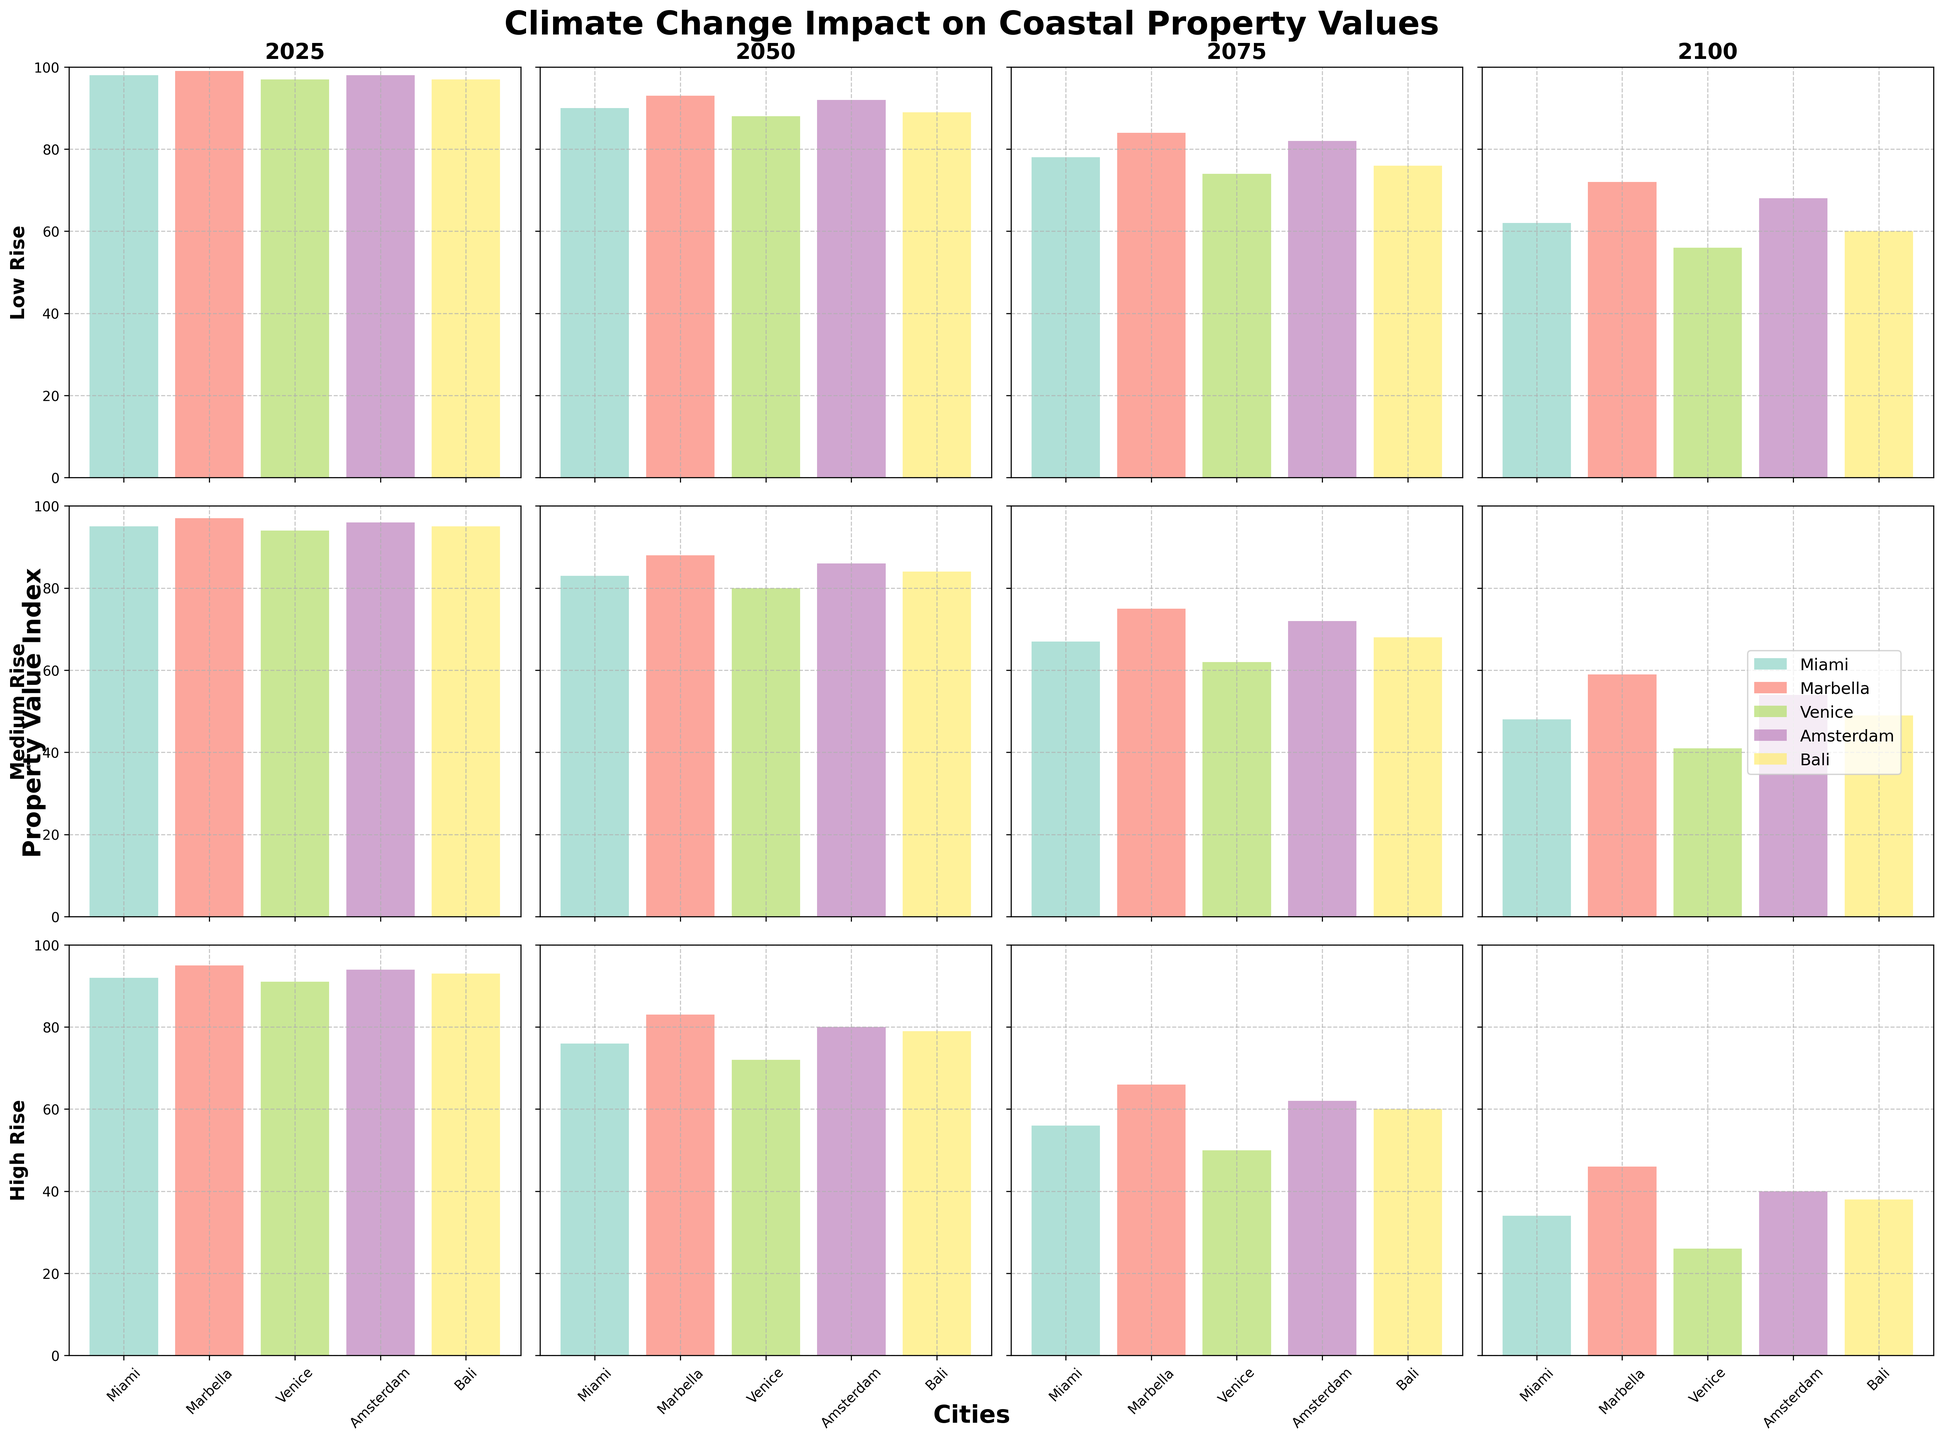what's the title of the figure? The title is typically located at the top of the figure. In this case, it reads "Climate Change Impact on Coastal Property Values".
Answer: Climate Change Impact on Coastal Property Values What city has the highest property value in the Low Rise scenario in 2025? For the 2025 Low Rise scenario, referring to the top left subplot, the city with the highest bar is Marbella.
Answer: Marbella How do property values in Miami compare between the Medium Rise and High Rise scenarios in 2075? First, locate the subplots for 2075. Then compare the bars for Miami in Medium Rise (67) and High Rise (56).
Answer: Miami has higher property values in the Medium Rise scenario (67) than in the High Rise scenario (56) What is the trend in Venice's property value from 2025 to 2100 in the Medium Rise scenario? Track the bar heights for Venice in the Medium Rise scenario across the years. The values are 94, 80, 62, 41. The trend shows a decrease.
Answer: Decreasing Which scenario in 2050 has the highest property value in Amsterdam? Referring to 2050, compare the heights of the Amsterdam bars across all scenarios. Low Rise has the highest value at 92.
Answer: Low Rise What is the average property value for Marbella in the year 2100 across all scenarios? For 2100, find the bars for Marbella in all scenarios: Low Rise (72), Medium Rise (59), High Rise (46). (72 + 59 + 46) / 3 = 59.
Answer: 59 How does property value in Bali under the Low Rise scenario in 2100 compare to that under the High Rise scenario in 2025? Compare the property value in Bali in Low Rise 2100 (60) to High Rise 2025 (93).
Answer: Lower in 2100 (60) than in 2025 (93) By what percentage does the property value in Venice decrease from 2025 to 2050 under the High Rise scenario? Calculate the percentage decrease: (97-72)/97 * 100% which gives approximately 25.77%.
Answer: 25.77% Which city shows the largest drop in property value from 2025 to 2075 for the High Rise scenario? Compare the property value changes from 2025 to 2075 for each city in the High Rise scenario. Venice changes from 91 to 50 (a decrease of 41), which is the largest drop.
Answer: Venice 